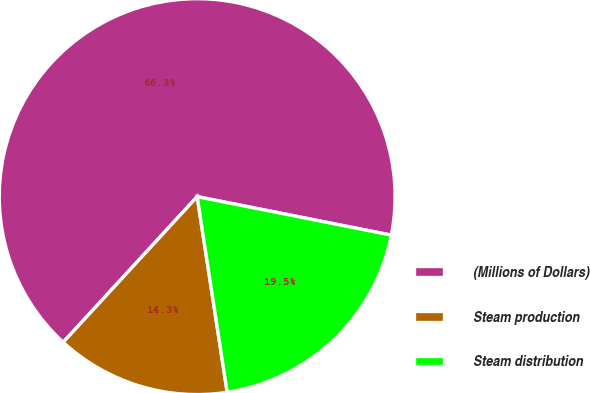Convert chart to OTSL. <chart><loc_0><loc_0><loc_500><loc_500><pie_chart><fcel>(Millions of Dollars)<fcel>Steam production<fcel>Steam distribution<nl><fcel>66.28%<fcel>14.26%<fcel>19.46%<nl></chart> 